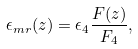Convert formula to latex. <formula><loc_0><loc_0><loc_500><loc_500>\epsilon _ { m r } ( z ) = \epsilon _ { 4 } \frac { F ( z ) } { F _ { 4 } } ,</formula> 